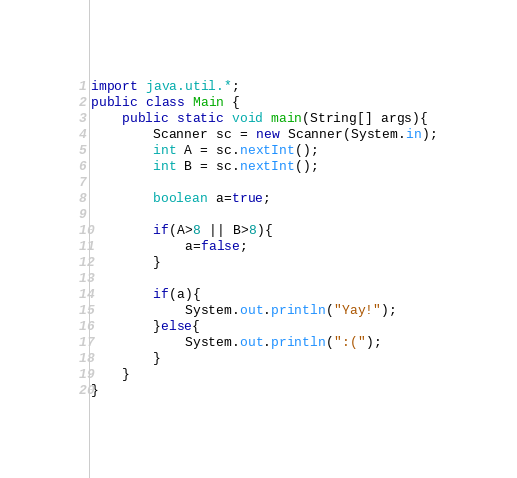Convert code to text. <code><loc_0><loc_0><loc_500><loc_500><_Java_>import java.util.*;
public class Main {
	public static void main(String[] args){
		Scanner sc = new Scanner(System.in);
		int A = sc.nextInt();
		int B = sc.nextInt();
		
		boolean a=true;
		
		if(A>8 || B>8){
			a=false;
		}
		
		if(a){
			System.out.println("Yay!");
		}else{
			System.out.println(":(");
		}
	}
}</code> 